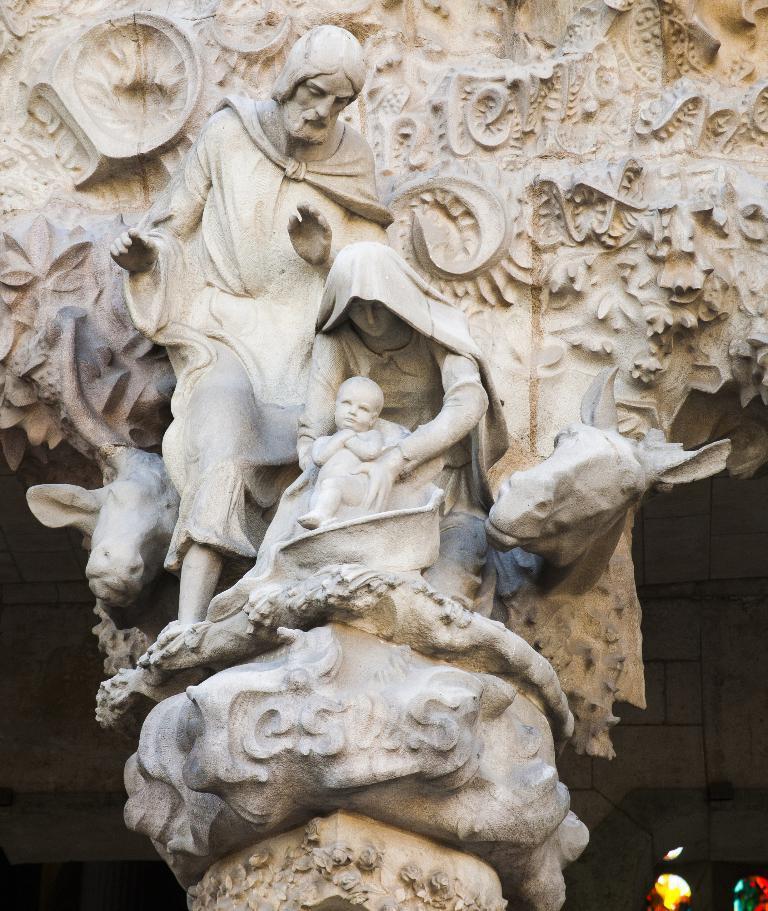Can you describe this image briefly? In the image i can see a three sculptures including animals and i can also see a text written on the stone. 